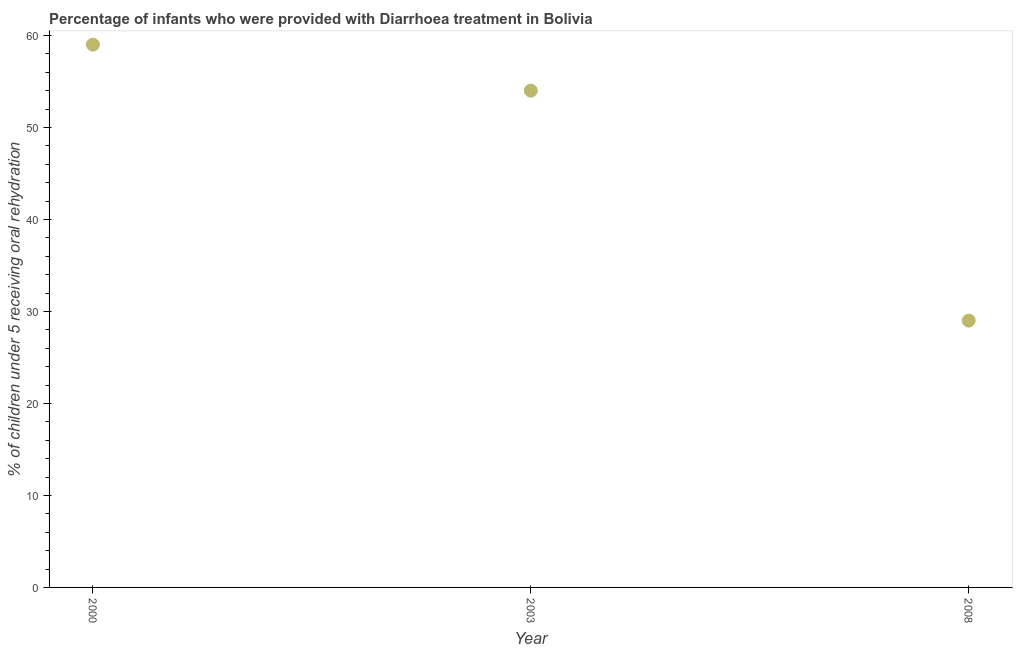What is the percentage of children who were provided with treatment diarrhoea in 2000?
Make the answer very short. 59. Across all years, what is the maximum percentage of children who were provided with treatment diarrhoea?
Provide a short and direct response. 59. Across all years, what is the minimum percentage of children who were provided with treatment diarrhoea?
Offer a very short reply. 29. In which year was the percentage of children who were provided with treatment diarrhoea maximum?
Give a very brief answer. 2000. In which year was the percentage of children who were provided with treatment diarrhoea minimum?
Ensure brevity in your answer.  2008. What is the sum of the percentage of children who were provided with treatment diarrhoea?
Offer a terse response. 142. What is the difference between the percentage of children who were provided with treatment diarrhoea in 2003 and 2008?
Provide a short and direct response. 25. What is the average percentage of children who were provided with treatment diarrhoea per year?
Provide a succinct answer. 47.33. What is the median percentage of children who were provided with treatment diarrhoea?
Offer a very short reply. 54. Do a majority of the years between 2000 and 2008 (inclusive) have percentage of children who were provided with treatment diarrhoea greater than 22 %?
Your response must be concise. Yes. What is the ratio of the percentage of children who were provided with treatment diarrhoea in 2003 to that in 2008?
Keep it short and to the point. 1.86. Is the difference between the percentage of children who were provided with treatment diarrhoea in 2003 and 2008 greater than the difference between any two years?
Keep it short and to the point. No. What is the difference between the highest and the second highest percentage of children who were provided with treatment diarrhoea?
Make the answer very short. 5. What is the difference between the highest and the lowest percentage of children who were provided with treatment diarrhoea?
Your response must be concise. 30. In how many years, is the percentage of children who were provided with treatment diarrhoea greater than the average percentage of children who were provided with treatment diarrhoea taken over all years?
Keep it short and to the point. 2. Does the percentage of children who were provided with treatment diarrhoea monotonically increase over the years?
Provide a short and direct response. No. How many dotlines are there?
Provide a succinct answer. 1. How many years are there in the graph?
Your answer should be compact. 3. Does the graph contain any zero values?
Ensure brevity in your answer.  No. What is the title of the graph?
Provide a short and direct response. Percentage of infants who were provided with Diarrhoea treatment in Bolivia. What is the label or title of the Y-axis?
Offer a very short reply. % of children under 5 receiving oral rehydration. What is the % of children under 5 receiving oral rehydration in 2000?
Provide a succinct answer. 59. What is the difference between the % of children under 5 receiving oral rehydration in 2003 and 2008?
Offer a terse response. 25. What is the ratio of the % of children under 5 receiving oral rehydration in 2000 to that in 2003?
Your answer should be very brief. 1.09. What is the ratio of the % of children under 5 receiving oral rehydration in 2000 to that in 2008?
Keep it short and to the point. 2.03. What is the ratio of the % of children under 5 receiving oral rehydration in 2003 to that in 2008?
Keep it short and to the point. 1.86. 